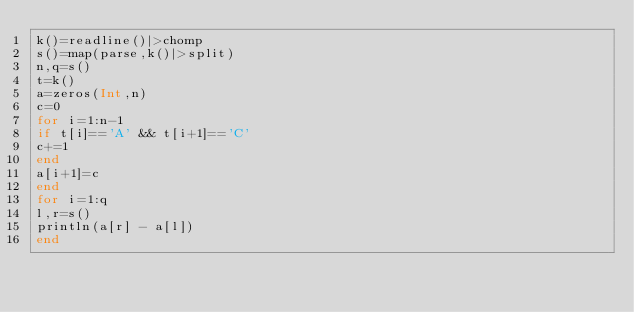Convert code to text. <code><loc_0><loc_0><loc_500><loc_500><_Julia_>k()=readline()|>chomp
s()=map(parse,k()|>split)
n,q=s()
t=k()
a=zeros(Int,n)
c=0
for i=1:n-1
if t[i]=='A' && t[i+1]=='C'
c+=1
end
a[i+1]=c
end
for i=1:q
l,r=s()
println(a[r] - a[l])
end</code> 